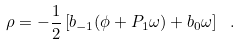<formula> <loc_0><loc_0><loc_500><loc_500>\rho = - \frac { 1 } { 2 } \left [ b _ { - 1 } ( \phi + P _ { 1 } \omega ) + b _ { 0 } \omega \right ] \ .</formula> 